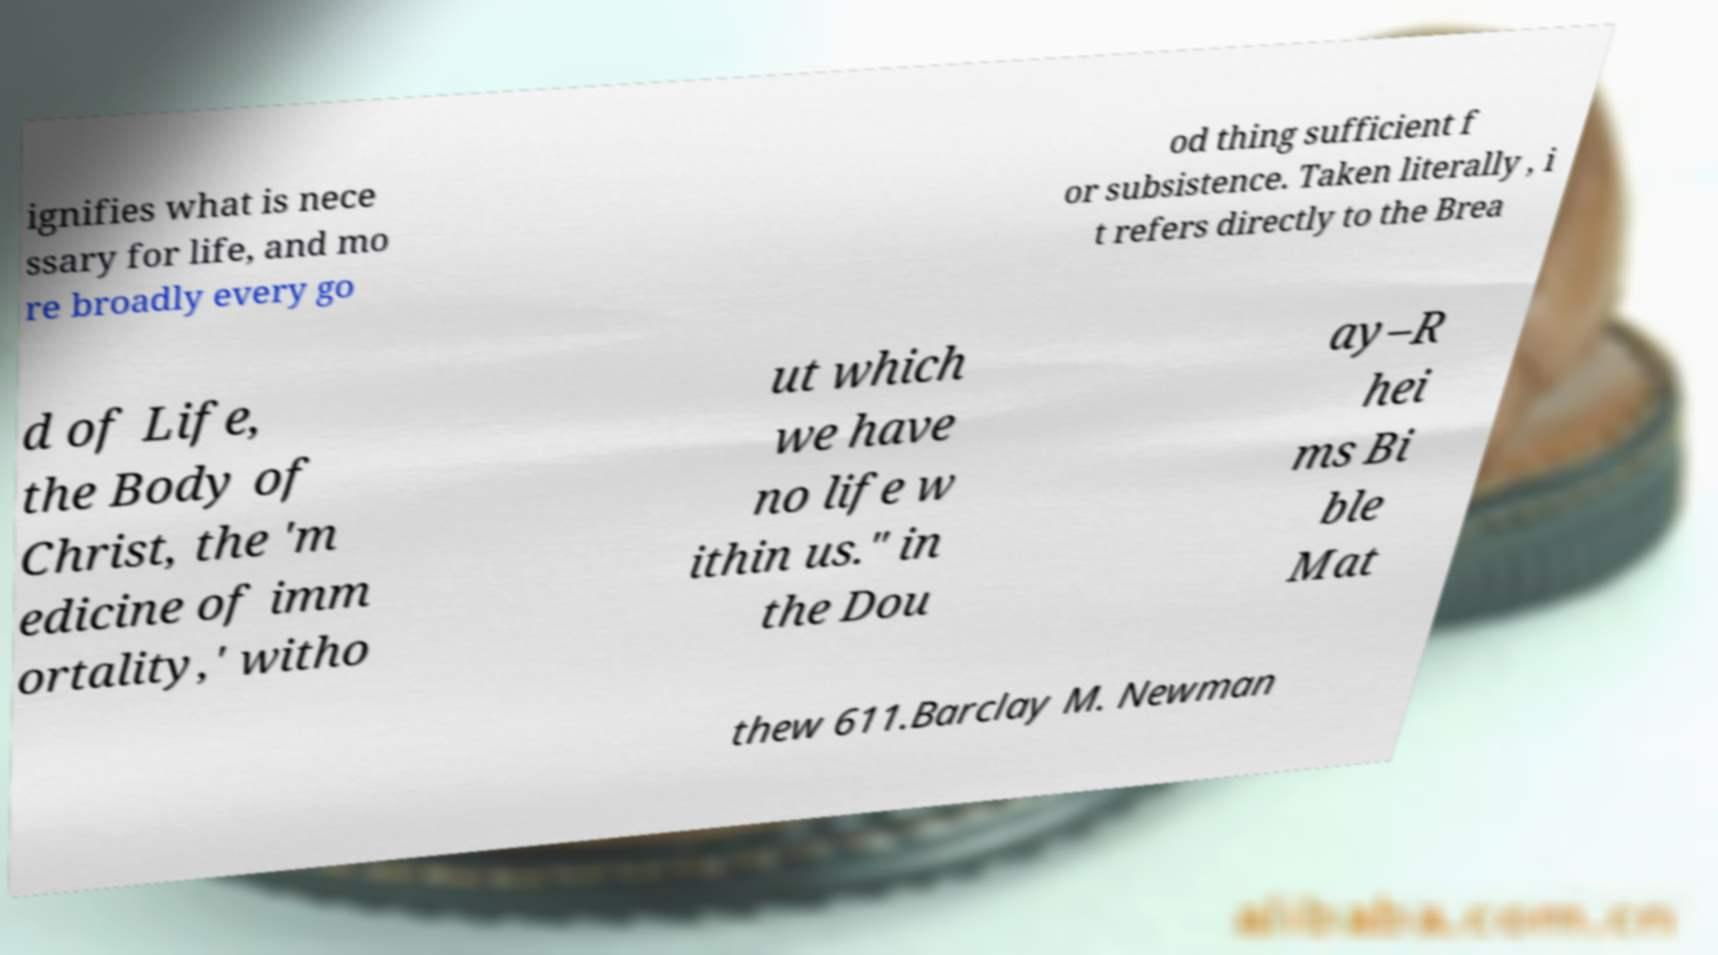For documentation purposes, I need the text within this image transcribed. Could you provide that? ignifies what is nece ssary for life, and mo re broadly every go od thing sufficient f or subsistence. Taken literally , i t refers directly to the Brea d of Life, the Body of Christ, the 'm edicine of imm ortality,' witho ut which we have no life w ithin us." in the Dou ay–R hei ms Bi ble Mat thew 611.Barclay M. Newman 